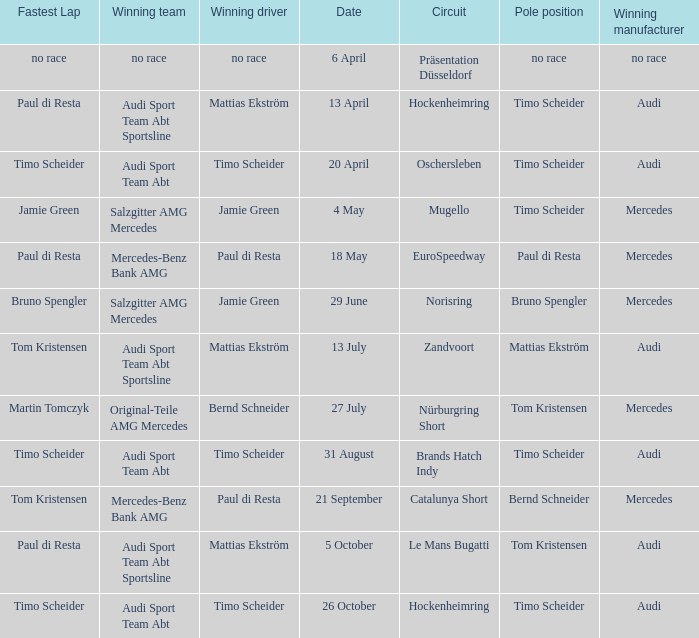Who is the winning driver of the race with no race as the winning manufacturer? No race. 